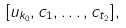Convert formula to latex. <formula><loc_0><loc_0><loc_500><loc_500>[ u _ { k _ { 0 } } , c _ { 1 } , \dots , c _ { t _ { 2 } } ] ,</formula> 